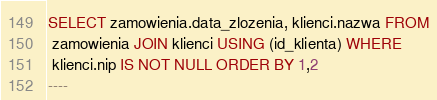<code> <loc_0><loc_0><loc_500><loc_500><_SQL_>SELECT zamowienia.data_zlozenia, klienci.nazwa FROM
 zamowienia JOIN klienci USING (id_klienta) WHERE 
 klienci.nip IS NOT NULL ORDER BY 1,2
----</code> 